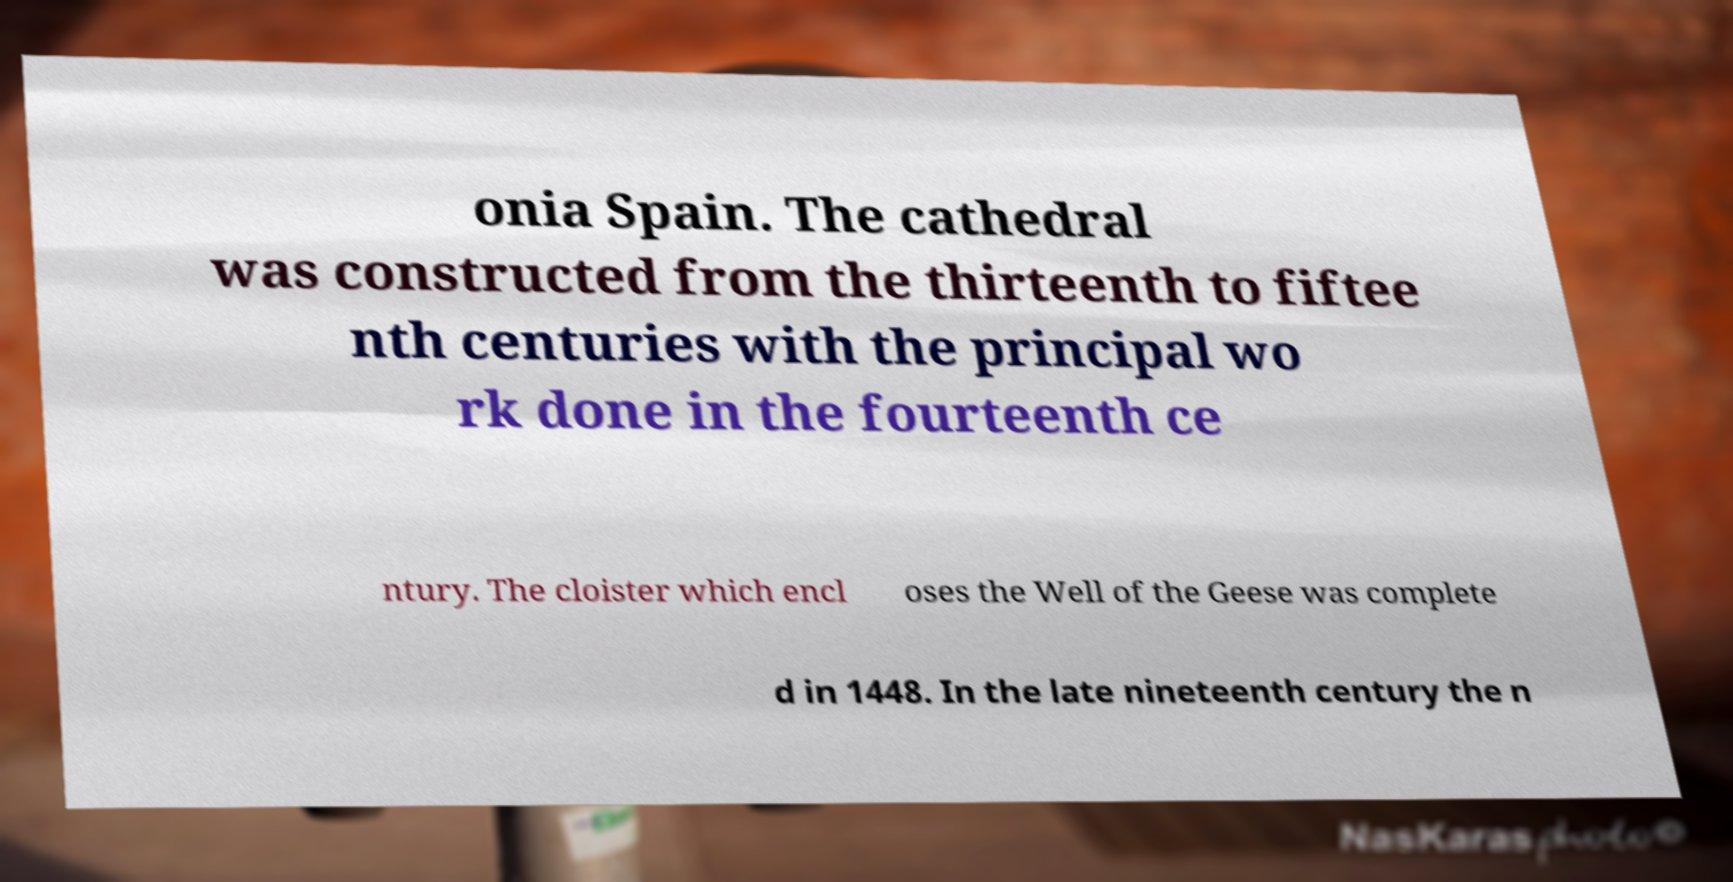Can you accurately transcribe the text from the provided image for me? onia Spain. The cathedral was constructed from the thirteenth to fiftee nth centuries with the principal wo rk done in the fourteenth ce ntury. The cloister which encl oses the Well of the Geese was complete d in 1448. In the late nineteenth century the n 